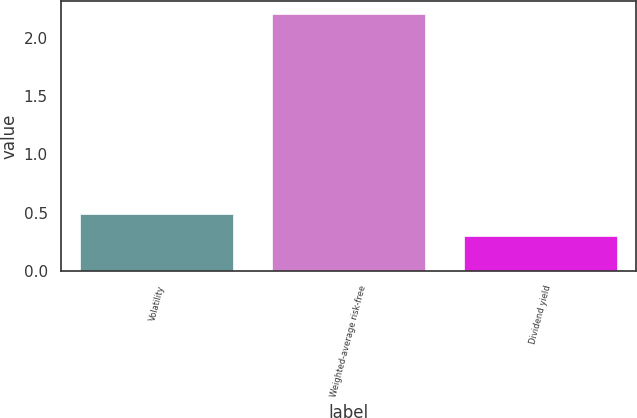Convert chart to OTSL. <chart><loc_0><loc_0><loc_500><loc_500><bar_chart><fcel>Volatility<fcel>Weighted-average risk-free<fcel>Dividend yield<nl><fcel>0.49<fcel>2.2<fcel>0.3<nl></chart> 